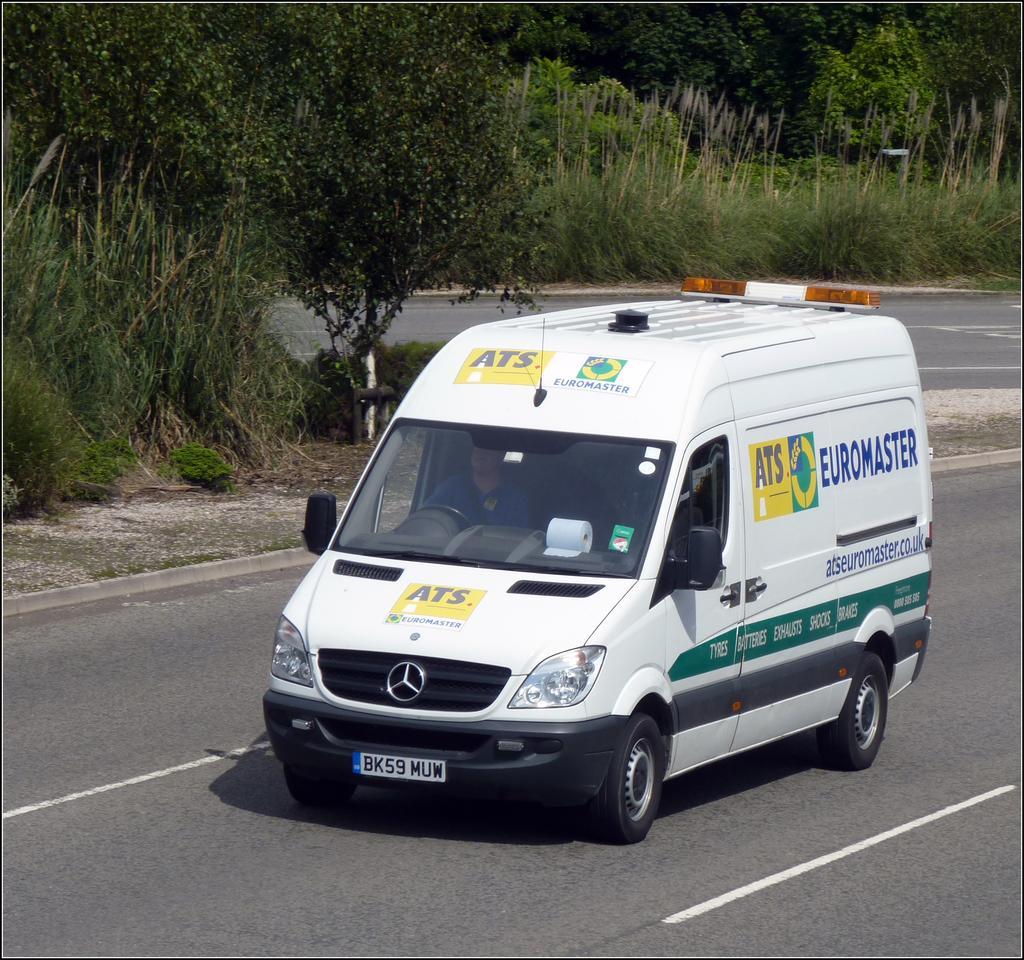Please provide a concise description of this image. In the picture there is a vehicle on the road and around the vehicle there are many trees and grass. 